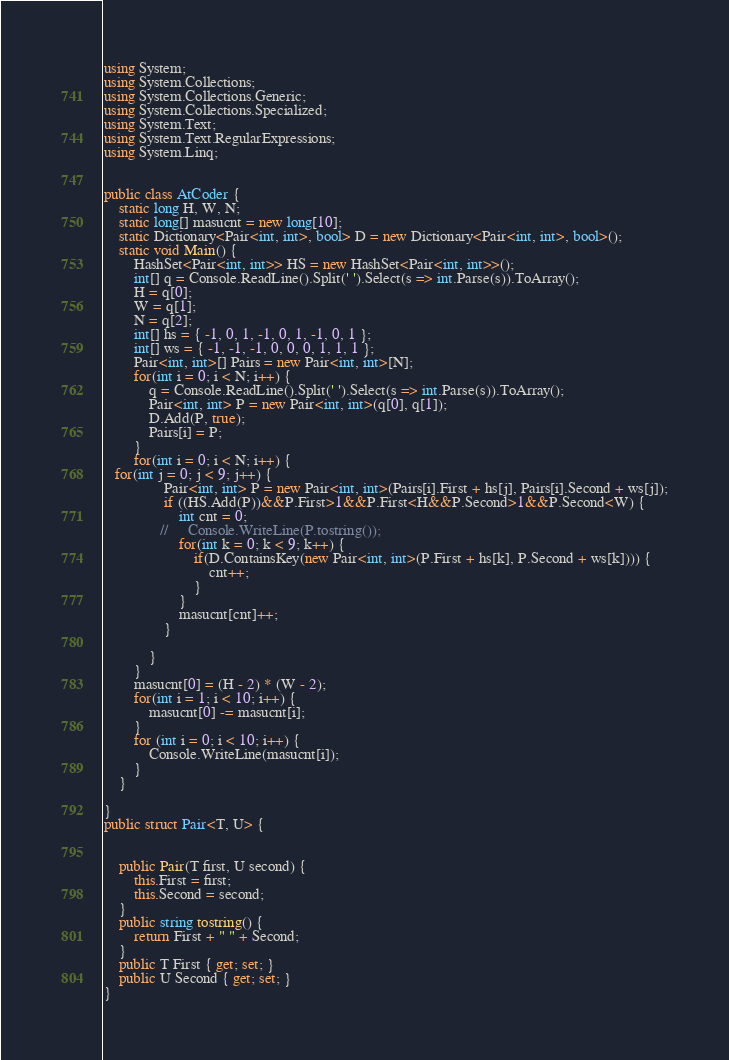Convert code to text. <code><loc_0><loc_0><loc_500><loc_500><_C#_>using System;
using System.Collections;
using System.Collections.Generic;
using System.Collections.Specialized;
using System.Text;
using System.Text.RegularExpressions;
using System.Linq;


public class AtCoder {
    static long H, W, N;
    static long[] masucnt = new long[10];
    static Dictionary<Pair<int, int>, bool> D = new Dictionary<Pair<int, int>, bool>();
    static void Main() {
        HashSet<Pair<int, int>> HS = new HashSet<Pair<int, int>>();
        int[] q = Console.ReadLine().Split(' ').Select(s => int.Parse(s)).ToArray();
        H = q[0];
        W = q[1];
        N = q[2];
        int[] hs = { -1, 0, 1, -1, 0, 1, -1, 0, 1 };
        int[] ws = { -1, -1, -1, 0, 0, 0, 1, 1, 1 };
        Pair<int, int>[] Pairs = new Pair<int, int>[N];
        for(int i = 0; i < N; i++) {
            q = Console.ReadLine().Split(' ').Select(s => int.Parse(s)).ToArray();
            Pair<int, int> P = new Pair<int, int>(q[0], q[1]);
            D.Add(P, true);
            Pairs[i] = P;
        }
        for(int i = 0; i < N; i++) {
   for(int j = 0; j < 9; j++) {
                Pair<int, int> P = new Pair<int, int>(Pairs[i].First + hs[j], Pairs[i].Second + ws[j]);
                if ((HS.Add(P))&&P.First>1&&P.First<H&&P.Second>1&&P.Second<W) {
                    int cnt = 0;
               //     Console.WriteLine(P.tostring());
                    for(int k = 0; k < 9; k++) {
                        if(D.ContainsKey(new Pair<int, int>(P.First + hs[k], P.Second + ws[k]))) {
                            cnt++;
                        }
                    }
                    masucnt[cnt]++;
                }
                
            }
        }
        masucnt[0] = (H - 2) * (W - 2);
        for(int i = 1; i < 10; i++) {
            masucnt[0] -= masucnt[i];
        }
        for (int i = 0; i < 10; i++) {
            Console.WriteLine(masucnt[i]);
        }
    }

}
public struct Pair<T, U> {
    

    public Pair(T first, U second) {
        this.First = first;
        this.Second = second;
    }
    public string tostring() {
        return First + " " + Second;
    }
    public T First { get; set; }
    public U Second { get; set; }
}</code> 